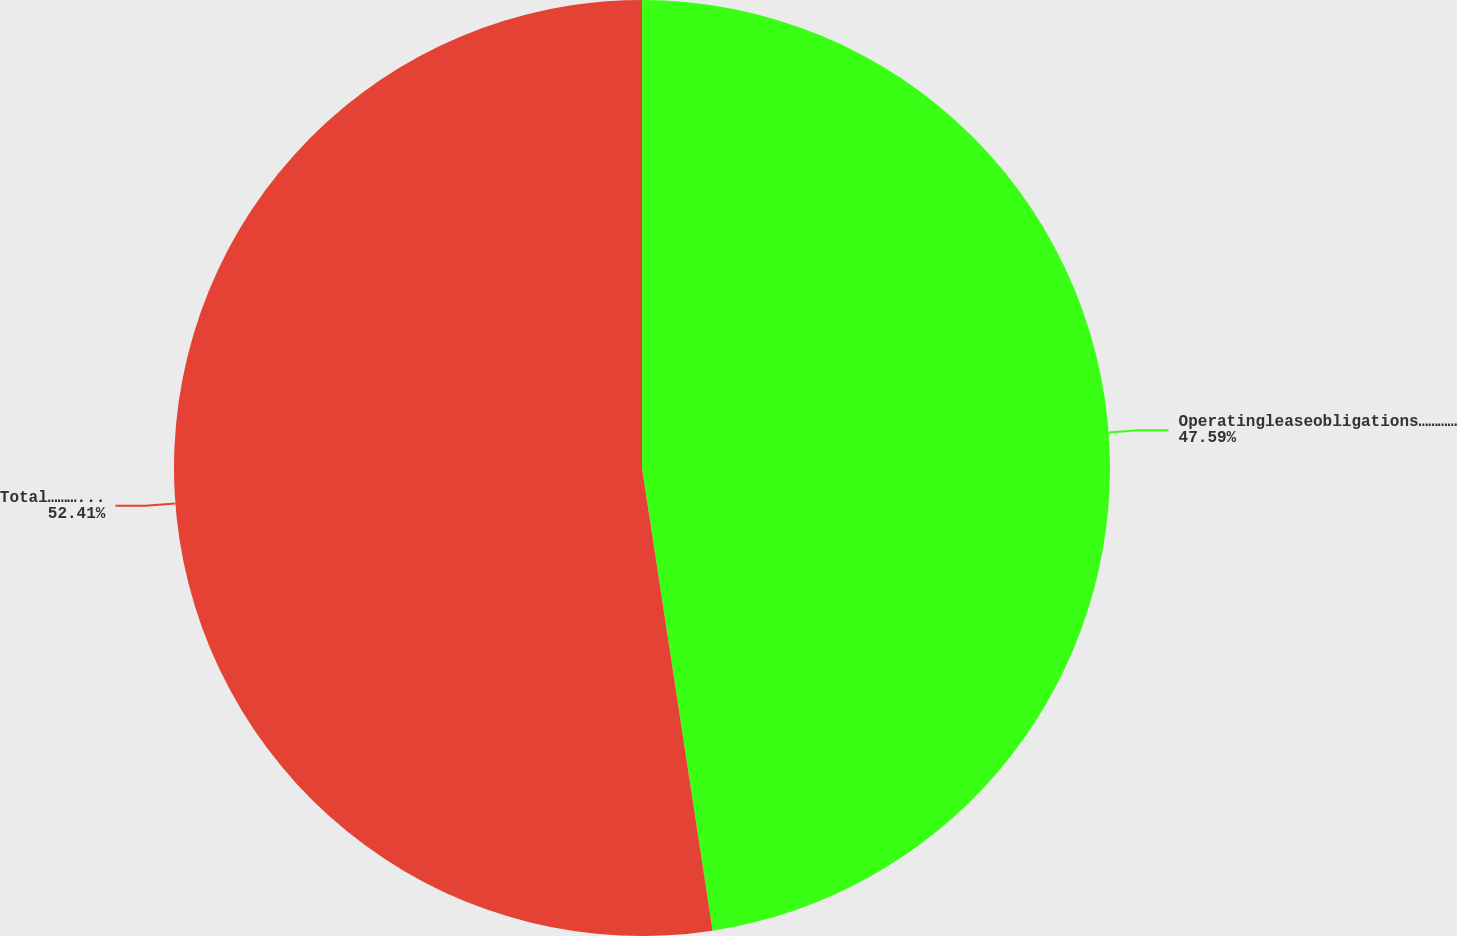<chart> <loc_0><loc_0><loc_500><loc_500><pie_chart><fcel>Operatingleaseobligations…………<fcel>Total…………………………………<nl><fcel>47.59%<fcel>52.41%<nl></chart> 